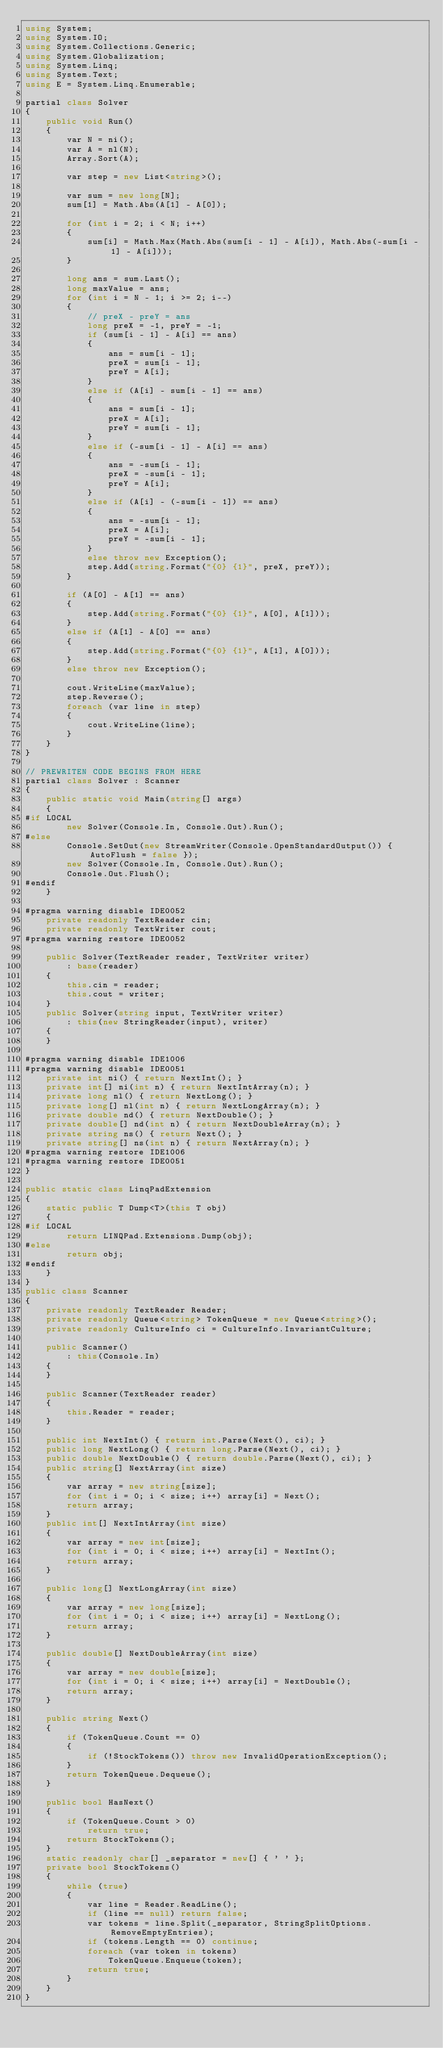<code> <loc_0><loc_0><loc_500><loc_500><_C#_>using System;
using System.IO;
using System.Collections.Generic;
using System.Globalization;
using System.Linq;
using System.Text;
using E = System.Linq.Enumerable;

partial class Solver
{
    public void Run()
    {
        var N = ni();
        var A = nl(N);
        Array.Sort(A);

        var step = new List<string>();

        var sum = new long[N];
        sum[1] = Math.Abs(A[1] - A[0]);

        for (int i = 2; i < N; i++)
        {
            sum[i] = Math.Max(Math.Abs(sum[i - 1] - A[i]), Math.Abs(-sum[i - 1] - A[i]));
        }

        long ans = sum.Last();
        long maxValue = ans;
        for (int i = N - 1; i >= 2; i--)
        {
            // preX - preY = ans
            long preX = -1, preY = -1;
            if (sum[i - 1] - A[i] == ans)
            {
                ans = sum[i - 1];
                preX = sum[i - 1];
                preY = A[i];
            }
            else if (A[i] - sum[i - 1] == ans)
            {
                ans = sum[i - 1];
                preX = A[i];
                preY = sum[i - 1];
            }
            else if (-sum[i - 1] - A[i] == ans)
            {
                ans = -sum[i - 1];
                preX = -sum[i - 1];
                preY = A[i];
            }
            else if (A[i] - (-sum[i - 1]) == ans)
            {
                ans = -sum[i - 1];
                preX = A[i];
                preY = -sum[i - 1];
            }
            else throw new Exception();
            step.Add(string.Format("{0} {1}", preX, preY));
        }

        if (A[0] - A[1] == ans)
        {
            step.Add(string.Format("{0} {1}", A[0], A[1]));
        }
        else if (A[1] - A[0] == ans)
        {
            step.Add(string.Format("{0} {1}", A[1], A[0]));
        }
        else throw new Exception();

        cout.WriteLine(maxValue);
        step.Reverse();
        foreach (var line in step)
        {
            cout.WriteLine(line);
        }
    }
}

// PREWRITEN CODE BEGINS FROM HERE
partial class Solver : Scanner
{
    public static void Main(string[] args)
    {
#if LOCAL
        new Solver(Console.In, Console.Out).Run();
#else
        Console.SetOut(new StreamWriter(Console.OpenStandardOutput()) { AutoFlush = false });
        new Solver(Console.In, Console.Out).Run();
        Console.Out.Flush();
#endif
    }

#pragma warning disable IDE0052
    private readonly TextReader cin;
    private readonly TextWriter cout;
#pragma warning restore IDE0052

    public Solver(TextReader reader, TextWriter writer)
        : base(reader)
    {
        this.cin = reader;
        this.cout = writer;
    }
    public Solver(string input, TextWriter writer)
        : this(new StringReader(input), writer)
    {
    }

#pragma warning disable IDE1006
#pragma warning disable IDE0051
    private int ni() { return NextInt(); }
    private int[] ni(int n) { return NextIntArray(n); }
    private long nl() { return NextLong(); }
    private long[] nl(int n) { return NextLongArray(n); }
    private double nd() { return NextDouble(); }
    private double[] nd(int n) { return NextDoubleArray(n); }
    private string ns() { return Next(); }
    private string[] ns(int n) { return NextArray(n); }
#pragma warning restore IDE1006
#pragma warning restore IDE0051
}

public static class LinqPadExtension
{
    static public T Dump<T>(this T obj)
    {
#if LOCAL
        return LINQPad.Extensions.Dump(obj);
#else
        return obj;
#endif
    }
}
public class Scanner
{
    private readonly TextReader Reader;
    private readonly Queue<string> TokenQueue = new Queue<string>();
    private readonly CultureInfo ci = CultureInfo.InvariantCulture;

    public Scanner()
        : this(Console.In)
    {
    }

    public Scanner(TextReader reader)
    {
        this.Reader = reader;
    }

    public int NextInt() { return int.Parse(Next(), ci); }
    public long NextLong() { return long.Parse(Next(), ci); }
    public double NextDouble() { return double.Parse(Next(), ci); }
    public string[] NextArray(int size)
    {
        var array = new string[size];
        for (int i = 0; i < size; i++) array[i] = Next();
        return array;
    }
    public int[] NextIntArray(int size)
    {
        var array = new int[size];
        for (int i = 0; i < size; i++) array[i] = NextInt();
        return array;
    }

    public long[] NextLongArray(int size)
    {
        var array = new long[size];
        for (int i = 0; i < size; i++) array[i] = NextLong();
        return array;
    }

    public double[] NextDoubleArray(int size)
    {
        var array = new double[size];
        for (int i = 0; i < size; i++) array[i] = NextDouble();
        return array;
    }

    public string Next()
    {
        if (TokenQueue.Count == 0)
        {
            if (!StockTokens()) throw new InvalidOperationException();
        }
        return TokenQueue.Dequeue();
    }

    public bool HasNext()
    {
        if (TokenQueue.Count > 0)
            return true;
        return StockTokens();
    }
    static readonly char[] _separator = new[] { ' ' };
    private bool StockTokens()
    {
        while (true)
        {
            var line = Reader.ReadLine();
            if (line == null) return false;
            var tokens = line.Split(_separator, StringSplitOptions.RemoveEmptyEntries);
            if (tokens.Length == 0) continue;
            foreach (var token in tokens)
                TokenQueue.Enqueue(token);
            return true;
        }
    }
}
</code> 